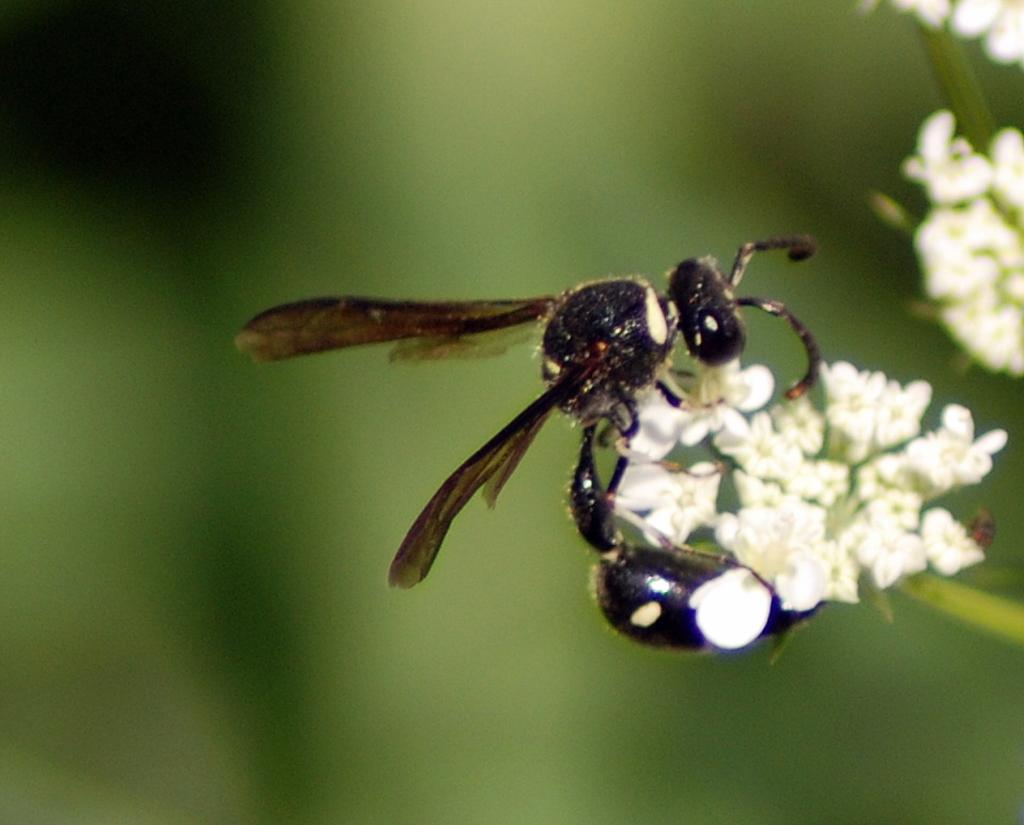What type of creatures can be seen in the image? There are insects in the image. Where are the insects located? The insects are on a bunch of flowers. What type of loaf can be seen in the image? There is no loaf present in the image; it features insects on a bunch of flowers. How many pancakes are visible in the image? There are no pancakes visible in the image. 